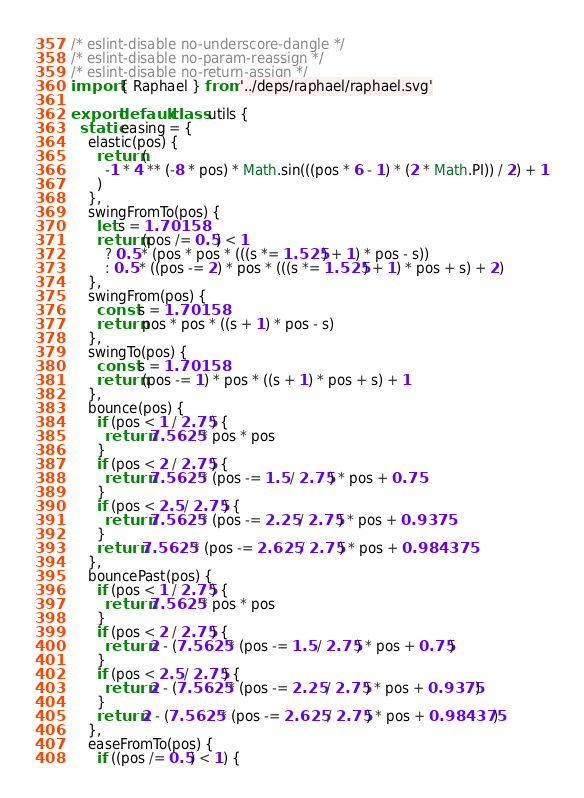Convert code to text. <code><loc_0><loc_0><loc_500><loc_500><_JavaScript_>/* eslint-disable no-underscore-dangle */
/* eslint-disable no-param-reassign */
/* eslint-disable no-return-assign */
import { Raphael } from '../deps/raphael/raphael.svg'

export default class utils {
  static easing = {
    elastic(pos) {
      return (
        -1 * 4 ** (-8 * pos) * Math.sin(((pos * 6 - 1) * (2 * Math.PI)) / 2) + 1
      )
    },
    swingFromTo(pos) {
      let s = 1.70158
      return (pos /= 0.5) < 1
        ? 0.5 * (pos * pos * (((s *= 1.525) + 1) * pos - s))
        : 0.5 * ((pos -= 2) * pos * (((s *= 1.525) + 1) * pos + s) + 2)
    },
    swingFrom(pos) {
      const s = 1.70158
      return pos * pos * ((s + 1) * pos - s)
    },
    swingTo(pos) {
      const s = 1.70158
      return (pos -= 1) * pos * ((s + 1) * pos + s) + 1
    },
    bounce(pos) {
      if (pos < 1 / 2.75) {
        return 7.5625 * pos * pos
      }
      if (pos < 2 / 2.75) {
        return 7.5625 * (pos -= 1.5 / 2.75) * pos + 0.75
      }
      if (pos < 2.5 / 2.75) {
        return 7.5625 * (pos -= 2.25 / 2.75) * pos + 0.9375
      }
      return 7.5625 * (pos -= 2.625 / 2.75) * pos + 0.984375
    },
    bouncePast(pos) {
      if (pos < 1 / 2.75) {
        return 7.5625 * pos * pos
      }
      if (pos < 2 / 2.75) {
        return 2 - (7.5625 * (pos -= 1.5 / 2.75) * pos + 0.75)
      }
      if (pos < 2.5 / 2.75) {
        return 2 - (7.5625 * (pos -= 2.25 / 2.75) * pos + 0.9375)
      }
      return 2 - (7.5625 * (pos -= 2.625 / 2.75) * pos + 0.984375)
    },
    easeFromTo(pos) {
      if ((pos /= 0.5) < 1) {</code> 